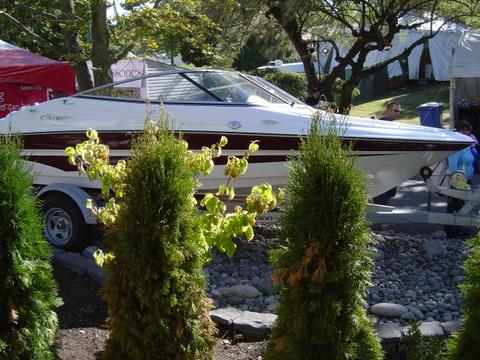What is the closest major city from this outdoor area? san francisco 